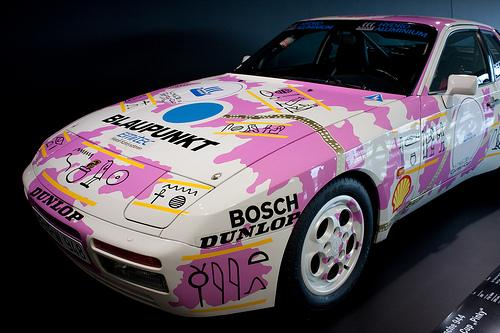What type of logo can be found on the side of the car? A red and white Shell logo is on the side of the car. Describe the visual content regarding the wheel and the rim. The wheel is black in color, and the rim is pink with a white design. What is the main subject in the image and what is its color? The main subject is a car and it is pink in color. Describe the appearance of the car windshield and its window. The front windshield is clear, and there is blue writing on the window. Can you identify any specific automobile parts in the image? Provide a brief description of their appearances. Some automobile parts include a white side mirror, a steering wheel, a front windshield, and a tire with a black rubber and pink and white rim. Summarize the visual content of the image in one sentence. The image shows a pink and white racecar with paint splotches, branded logos, and various visible automobile parts. List the colors of these objects: circles, paint splotches, and the car itself. The circle is blue, the paint splotches are pink, and the car is pink and white. What is the color and type of the car mirror in the image? The car mirror is white and it is a side mirror. How many different written or visual logos can be seen on the car? There are six logos: Shell, Blaupunkt, Bosch, Dunlop (2 times), and blue triangle with white design. Provide a sentiment analysis of the image based on its visual aspects. The image evokes fun and creativity due to the mix of bright colors and artistic paint splotches on the car. 